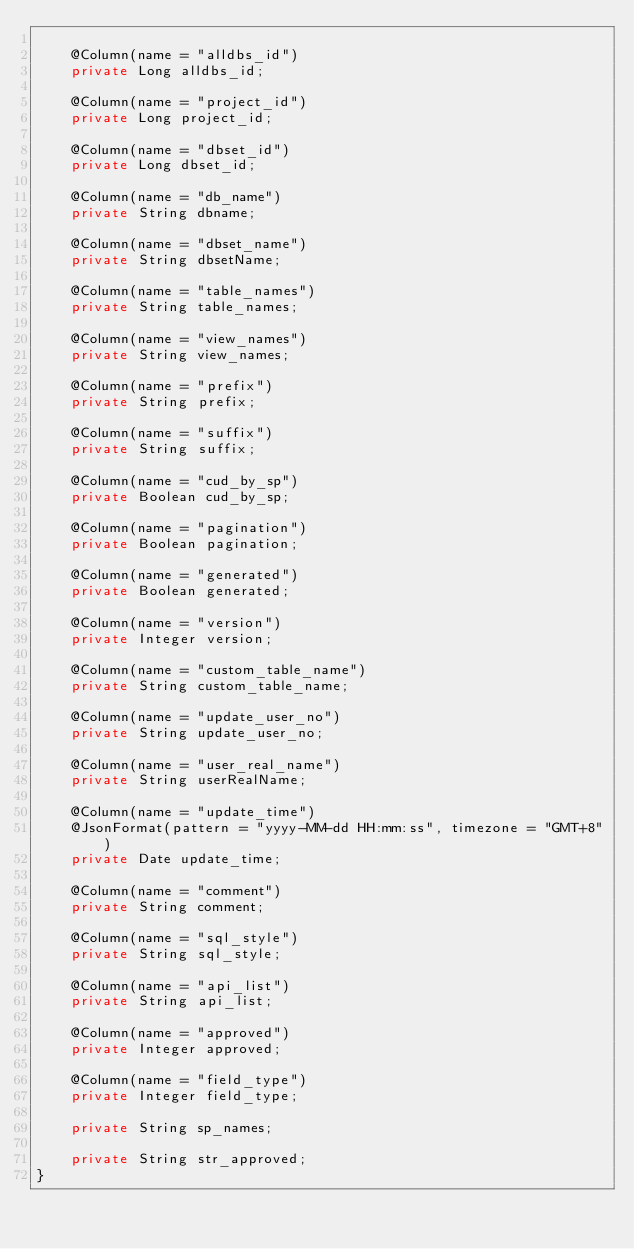Convert code to text. <code><loc_0><loc_0><loc_500><loc_500><_Java_>
    @Column(name = "alldbs_id")
    private Long alldbs_id;

    @Column(name = "project_id")
    private Long project_id;

    @Column(name = "dbset_id")
    private Long dbset_id;

    @Column(name = "db_name")
    private String dbname;

    @Column(name = "dbset_name")
    private String dbsetName;

    @Column(name = "table_names")
    private String table_names;

    @Column(name = "view_names")
    private String view_names;

    @Column(name = "prefix")
    private String prefix;

    @Column(name = "suffix")
    private String suffix;

    @Column(name = "cud_by_sp")
    private Boolean cud_by_sp;

    @Column(name = "pagination")
    private Boolean pagination;

    @Column(name = "generated")
    private Boolean generated;

    @Column(name = "version")
    private Integer version;

    @Column(name = "custom_table_name")
    private String custom_table_name;

    @Column(name = "update_user_no")
    private String update_user_no;

    @Column(name = "user_real_name")
    private String userRealName;

    @Column(name = "update_time")
    @JsonFormat(pattern = "yyyy-MM-dd HH:mm:ss", timezone = "GMT+8")
    private Date update_time;

    @Column(name = "comment")
    private String comment;

    @Column(name = "sql_style")
    private String sql_style;

    @Column(name = "api_list")
    private String api_list;

    @Column(name = "approved")
    private Integer approved;

    @Column(name = "field_type")
    private Integer field_type;

    private String sp_names;

    private String str_approved;
}
</code> 